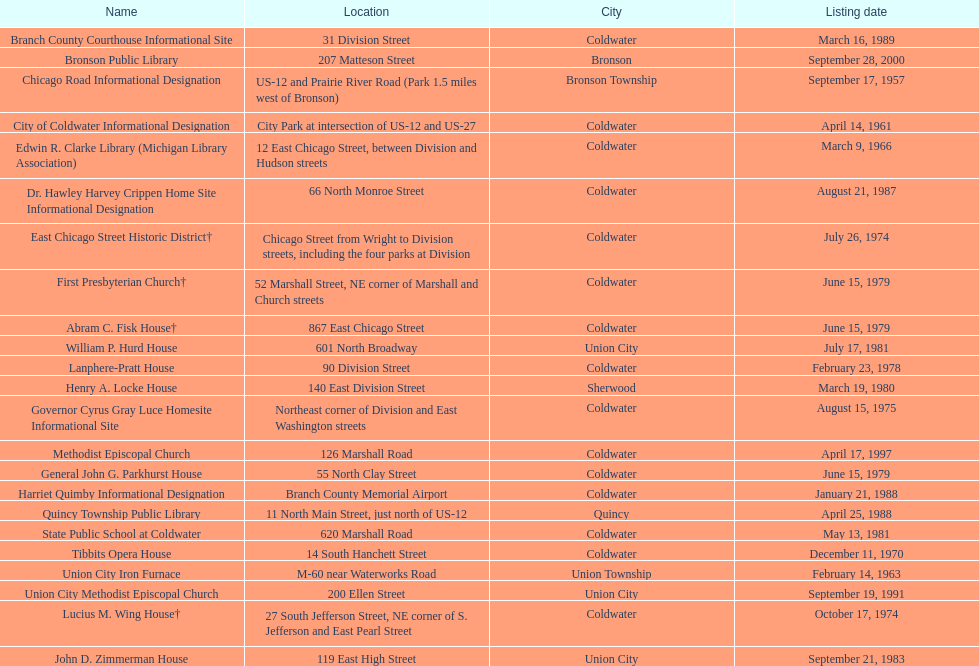Which city is home to the greatest number of historic landmarks? Coldwater. 